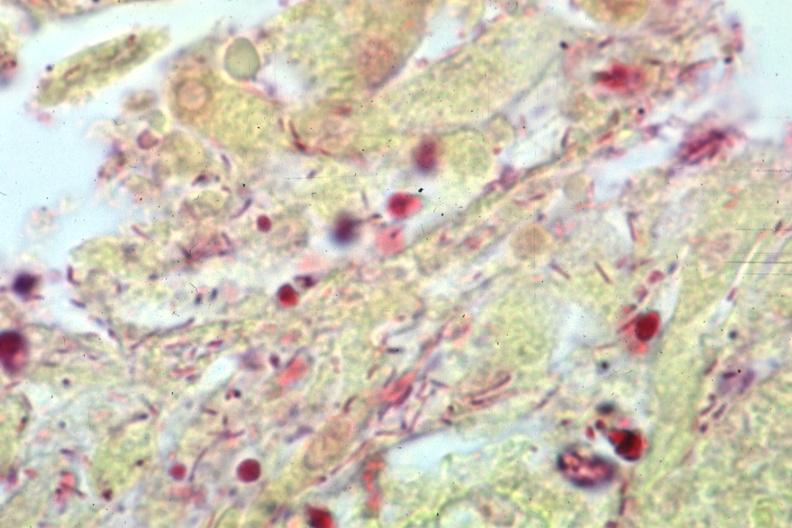how does gram stain gram bacteria?
Answer the question using a single word or phrase. Negative 